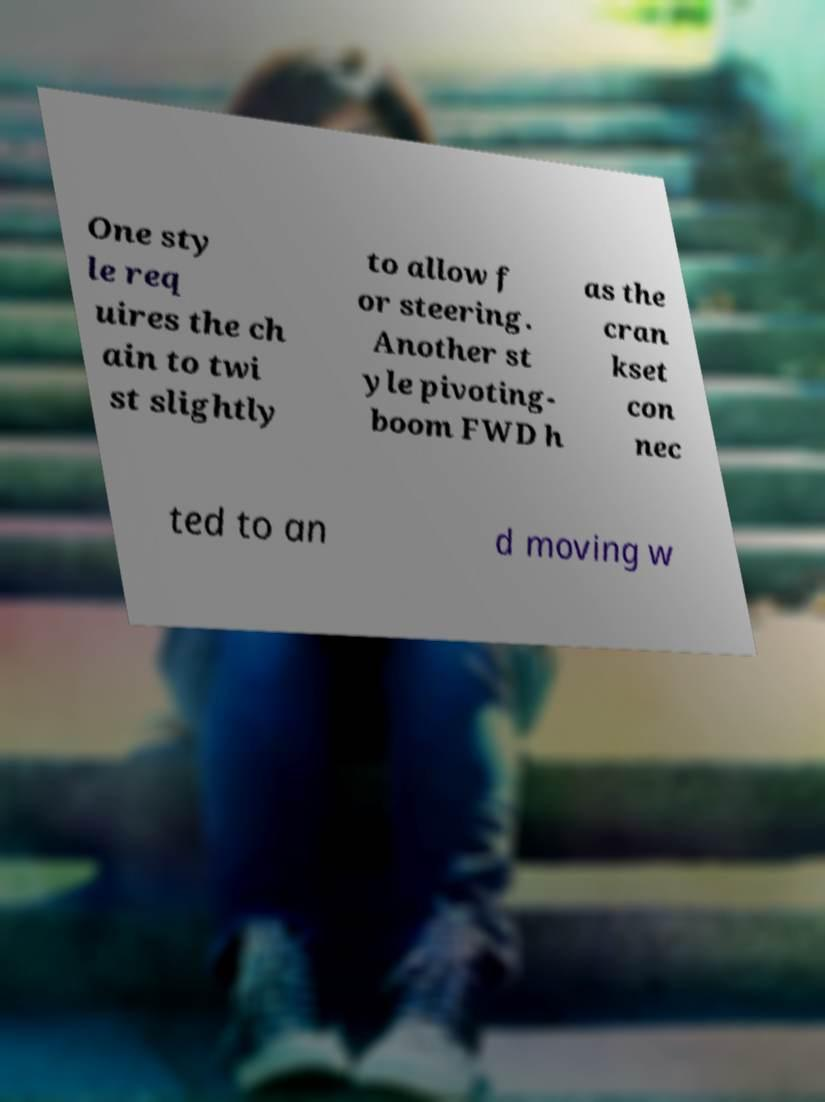There's text embedded in this image that I need extracted. Can you transcribe it verbatim? One sty le req uires the ch ain to twi st slightly to allow f or steering. Another st yle pivoting- boom FWD h as the cran kset con nec ted to an d moving w 